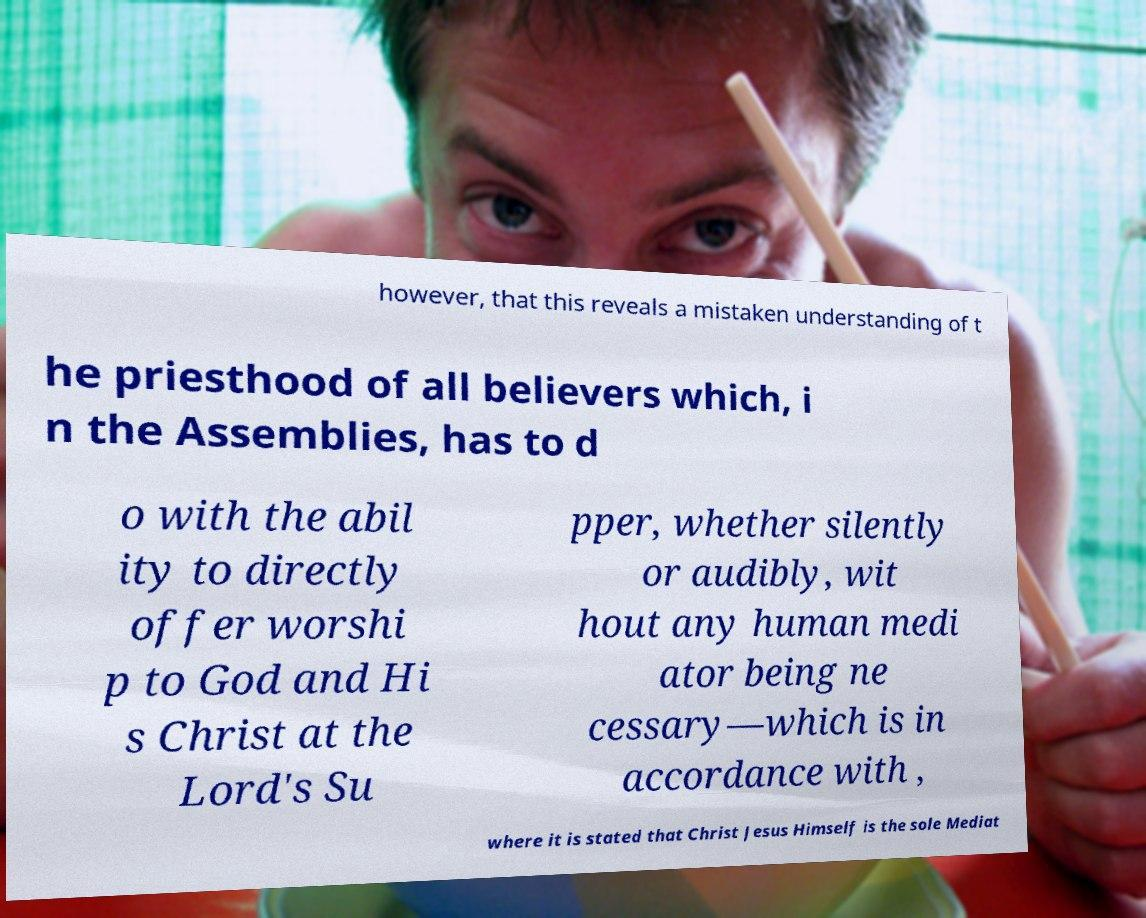Please read and relay the text visible in this image. What does it say? however, that this reveals a mistaken understanding of t he priesthood of all believers which, i n the Assemblies, has to d o with the abil ity to directly offer worshi p to God and Hi s Christ at the Lord's Su pper, whether silently or audibly, wit hout any human medi ator being ne cessary—which is in accordance with , where it is stated that Christ Jesus Himself is the sole Mediat 